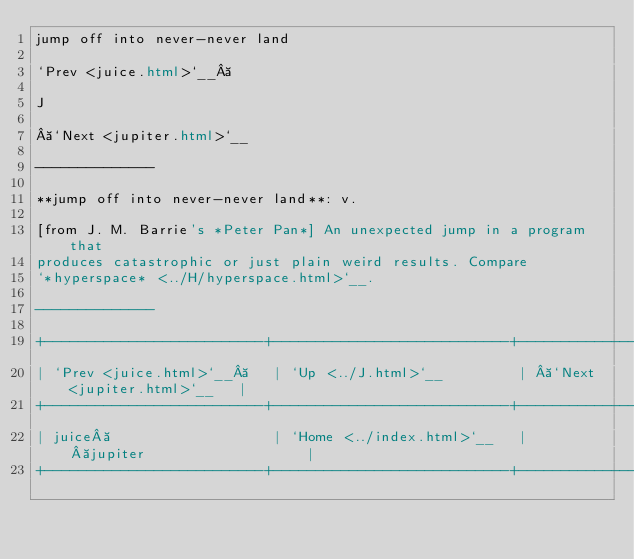Convert code to text. <code><loc_0><loc_0><loc_500><loc_500><_HTML_>jump off into never-never land

`Prev <juice.html>`__ 

J

 `Next <jupiter.html>`__

--------------

**jump off into never-never land**: v.

[from J. M. Barrie's *Peter Pan*] An unexpected jump in a program that
produces catastrophic or just plain weird results. Compare
`*hyperspace* <../H/hyperspace.html>`__.

--------------

+--------------------------+----------------------------+----------------------------+
| `Prev <juice.html>`__    | `Up <../J.html>`__         |  `Next <jupiter.html>`__   |
+--------------------------+----------------------------+----------------------------+
| juice                    | `Home <../index.html>`__   |  jupiter                   |
+--------------------------+----------------------------+----------------------------+

</code> 